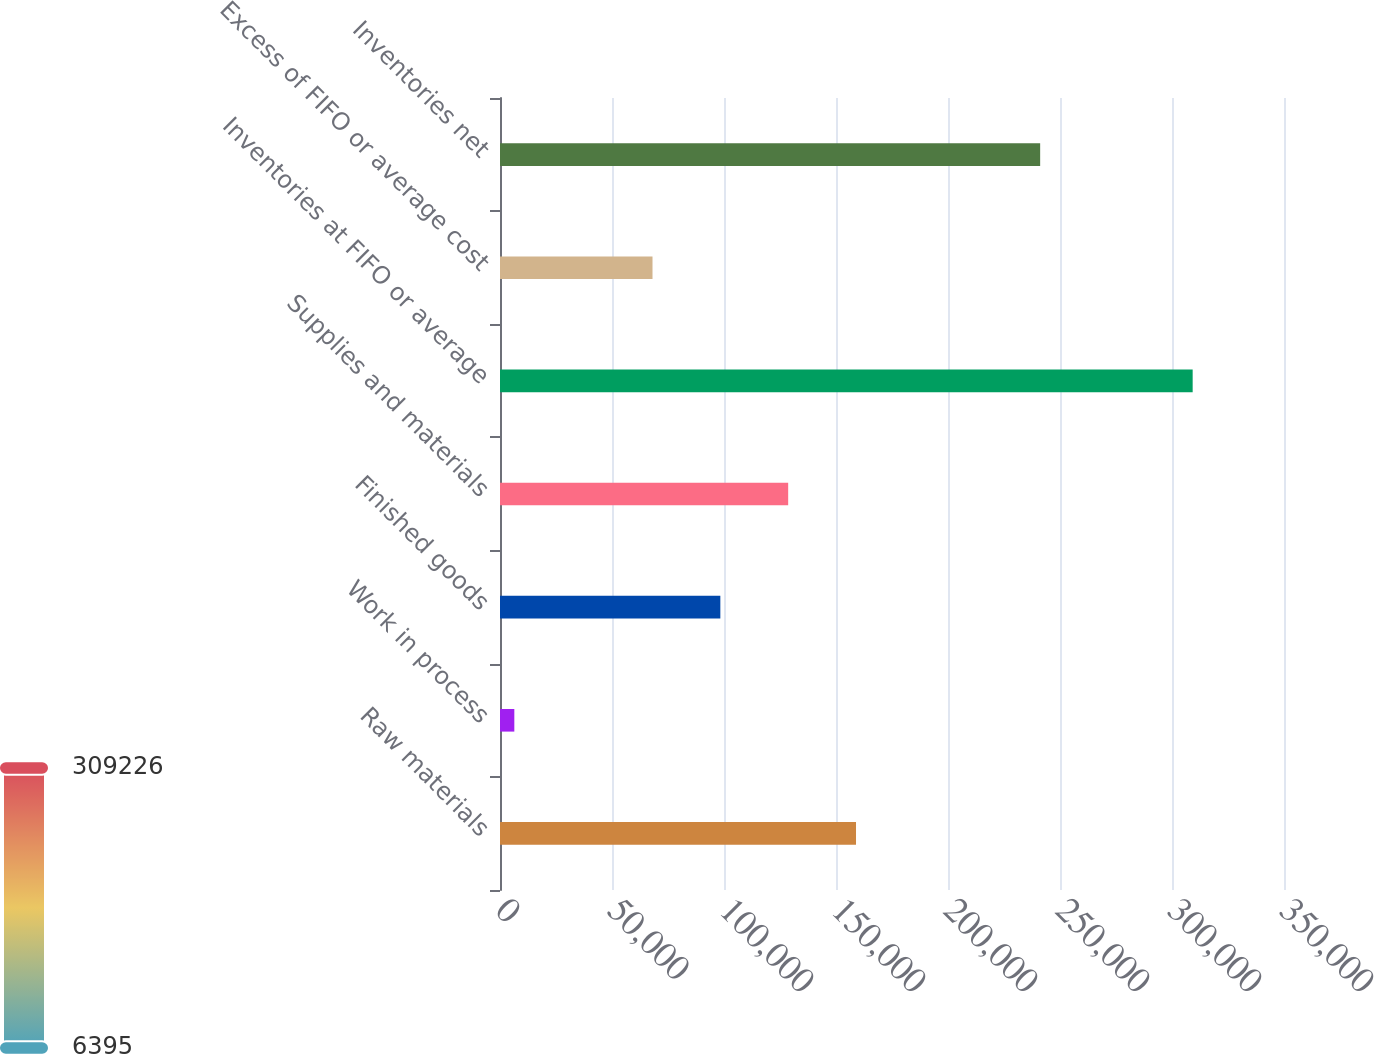<chart> <loc_0><loc_0><loc_500><loc_500><bar_chart><fcel>Raw materials<fcel>Work in process<fcel>Finished goods<fcel>Supplies and materials<fcel>Inventories at FIFO or average<fcel>Excess of FIFO or average cost<fcel>Inventories net<nl><fcel>158933<fcel>6395<fcel>98367.1<fcel>128650<fcel>309226<fcel>68084<fcel>241142<nl></chart> 